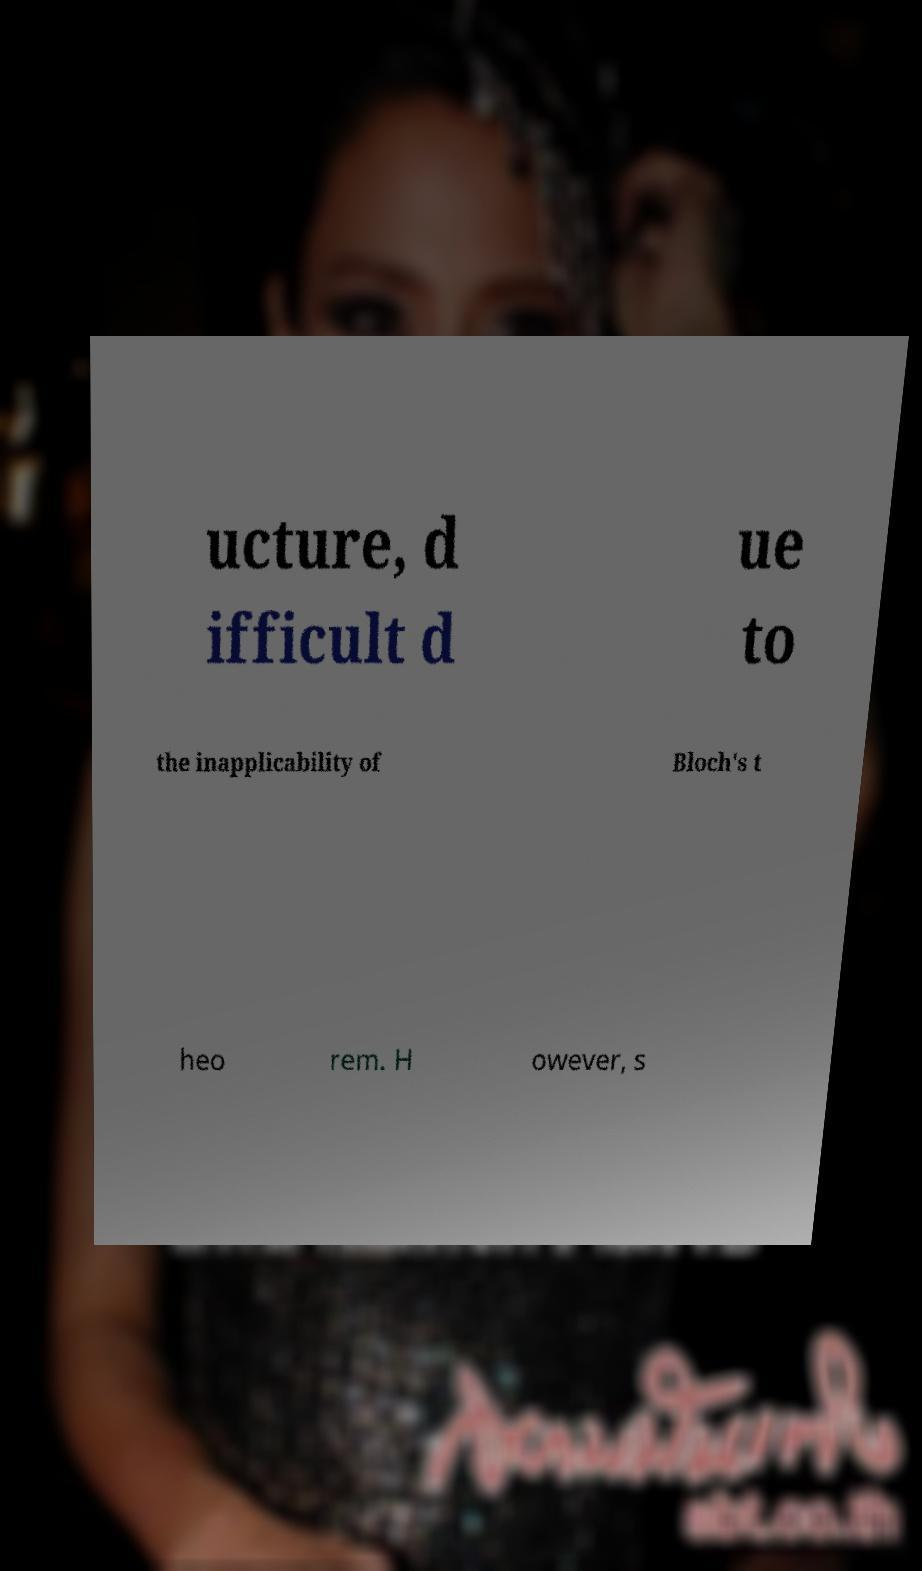Please identify and transcribe the text found in this image. ucture, d ifficult d ue to the inapplicability of Bloch's t heo rem. H owever, s 